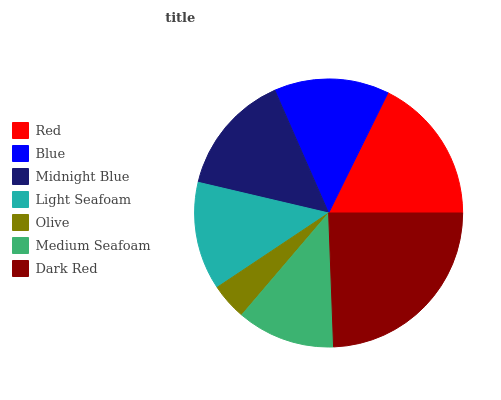Is Olive the minimum?
Answer yes or no. Yes. Is Dark Red the maximum?
Answer yes or no. Yes. Is Blue the minimum?
Answer yes or no. No. Is Blue the maximum?
Answer yes or no. No. Is Red greater than Blue?
Answer yes or no. Yes. Is Blue less than Red?
Answer yes or no. Yes. Is Blue greater than Red?
Answer yes or no. No. Is Red less than Blue?
Answer yes or no. No. Is Blue the high median?
Answer yes or no. Yes. Is Blue the low median?
Answer yes or no. Yes. Is Midnight Blue the high median?
Answer yes or no. No. Is Olive the low median?
Answer yes or no. No. 